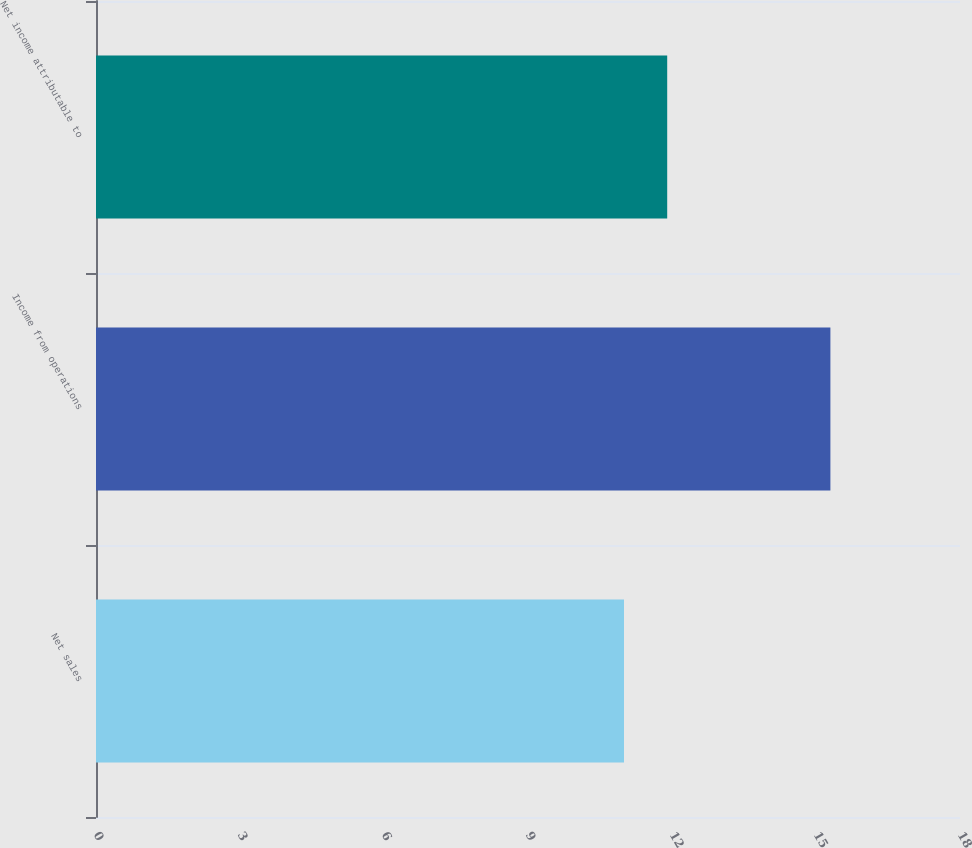Convert chart to OTSL. <chart><loc_0><loc_0><loc_500><loc_500><bar_chart><fcel>Net sales<fcel>Income from operations<fcel>Net income attributable to<nl><fcel>11<fcel>15.3<fcel>11.9<nl></chart> 